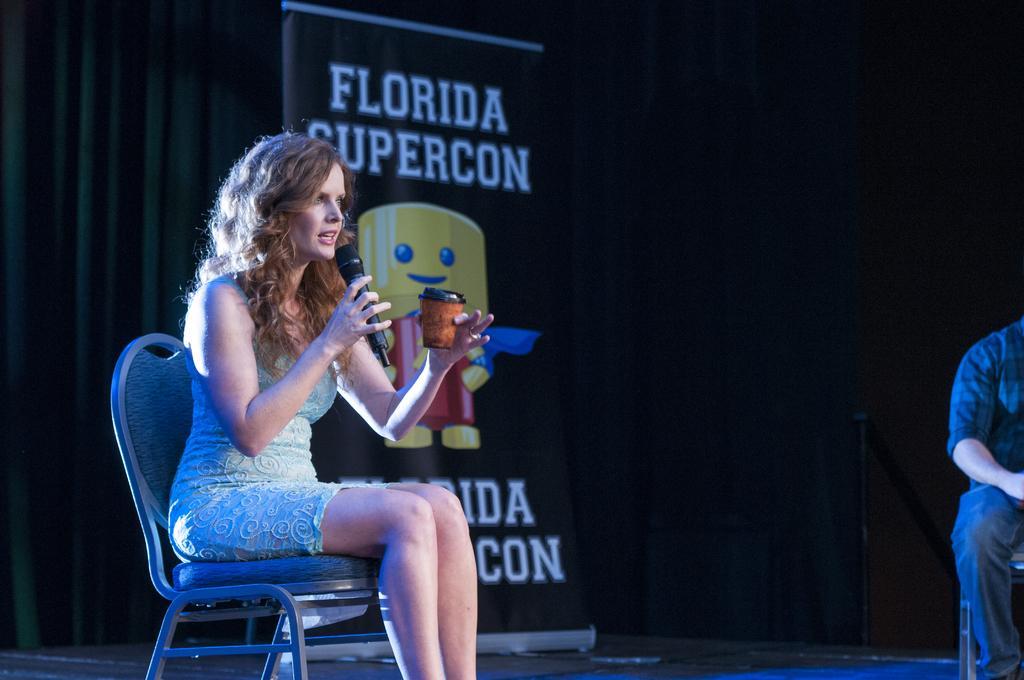How would you summarize this image in a sentence or two? A woman is sitting in a chair. She is speaking with mic in her hand. There is a cup in other hand. There is a flex banner title "Florida supercon". 